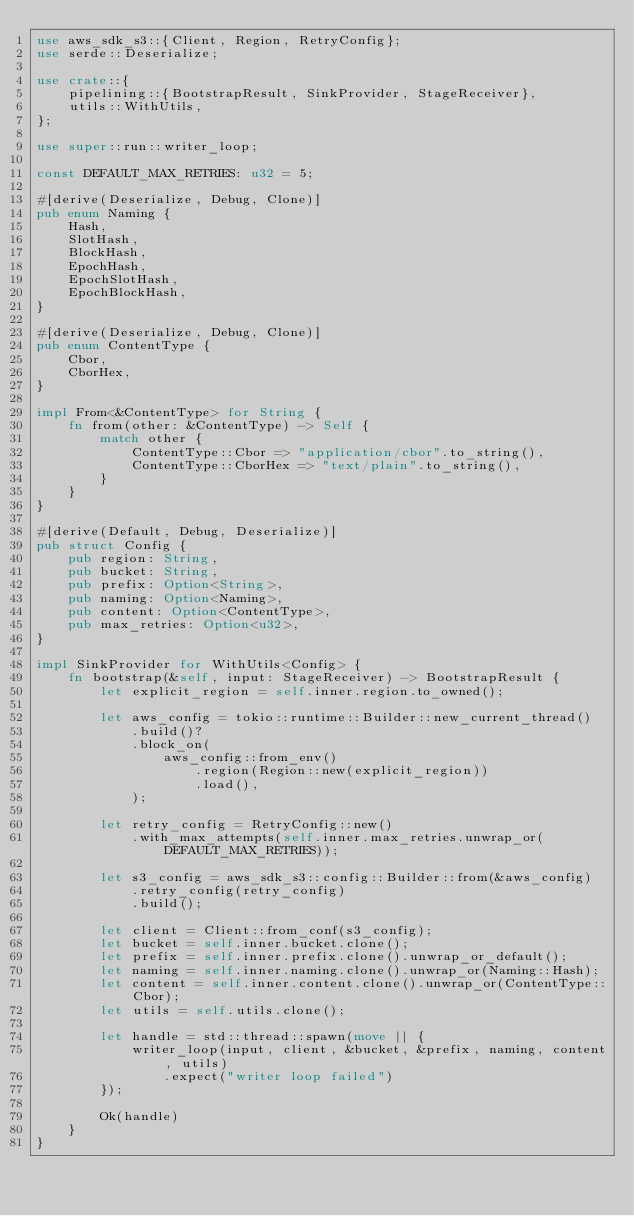Convert code to text. <code><loc_0><loc_0><loc_500><loc_500><_Rust_>use aws_sdk_s3::{Client, Region, RetryConfig};
use serde::Deserialize;

use crate::{
    pipelining::{BootstrapResult, SinkProvider, StageReceiver},
    utils::WithUtils,
};

use super::run::writer_loop;

const DEFAULT_MAX_RETRIES: u32 = 5;

#[derive(Deserialize, Debug, Clone)]
pub enum Naming {
    Hash,
    SlotHash,
    BlockHash,
    EpochHash,
    EpochSlotHash,
    EpochBlockHash,
}

#[derive(Deserialize, Debug, Clone)]
pub enum ContentType {
    Cbor,
    CborHex,
}

impl From<&ContentType> for String {
    fn from(other: &ContentType) -> Self {
        match other {
            ContentType::Cbor => "application/cbor".to_string(),
            ContentType::CborHex => "text/plain".to_string(),
        }
    }
}

#[derive(Default, Debug, Deserialize)]
pub struct Config {
    pub region: String,
    pub bucket: String,
    pub prefix: Option<String>,
    pub naming: Option<Naming>,
    pub content: Option<ContentType>,
    pub max_retries: Option<u32>,
}

impl SinkProvider for WithUtils<Config> {
    fn bootstrap(&self, input: StageReceiver) -> BootstrapResult {
        let explicit_region = self.inner.region.to_owned();

        let aws_config = tokio::runtime::Builder::new_current_thread()
            .build()?
            .block_on(
                aws_config::from_env()
                    .region(Region::new(explicit_region))
                    .load(),
            );

        let retry_config = RetryConfig::new()
            .with_max_attempts(self.inner.max_retries.unwrap_or(DEFAULT_MAX_RETRIES));

        let s3_config = aws_sdk_s3::config::Builder::from(&aws_config)
            .retry_config(retry_config)
            .build();

        let client = Client::from_conf(s3_config);
        let bucket = self.inner.bucket.clone();
        let prefix = self.inner.prefix.clone().unwrap_or_default();
        let naming = self.inner.naming.clone().unwrap_or(Naming::Hash);
        let content = self.inner.content.clone().unwrap_or(ContentType::Cbor);
        let utils = self.utils.clone();

        let handle = std::thread::spawn(move || {
            writer_loop(input, client, &bucket, &prefix, naming, content, utils)
                .expect("writer loop failed")
        });

        Ok(handle)
    }
}
</code> 